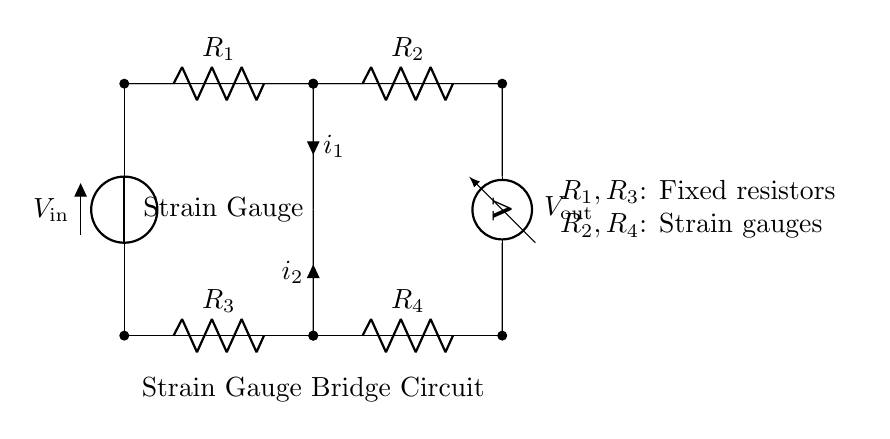What is the input voltage? The input voltage is labeled as V_in, which indicates the potential difference applied across the circuit.
Answer: V_in What are R_1 and R_3? R_1 and R_3 are labeled as fixed resistors in the circuit diagram, which serve as reference resistors in the bridge configuration.
Answer: Fixed resistors What does the strain gauge measure? The strain gauge measures small changes in force or pressure by detecting strain, which changes its resistance in the bridge circuit.
Answer: Strain What is the relationship between i_1 and i_2 in the circuit? In a balanced Wheatstone bridge, the relationship is that i_1 will equal i_2 when there is no change in resistance due to external force, leading to no current flow through the strain gauge.
Answer: Equal How does the output voltage relate to the resistance change? The output voltage (V_out) is directly proportional to the difference in resistance between the pairs R_2 and R_4, and R_1 and R_3, indicating changing force or pressure.
Answer: Proportional What type of circuit is this? This is a strain gauge bridge circuit, specifically designed to detect small changes in resistance caused by strain from applied force or pressure.
Answer: Strain gauge bridge circuit 